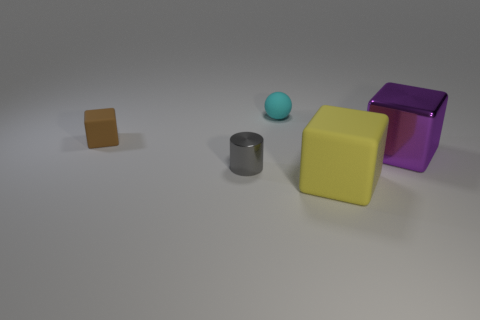There is a tiny cyan object that is made of the same material as the yellow object; what is its shape?
Your answer should be very brief. Sphere. Is there any other thing that has the same color as the tiny block?
Offer a terse response. No. What is the small object that is behind the matte cube on the left side of the small cyan sphere made of?
Offer a very short reply. Rubber. Are there any tiny cyan objects of the same shape as the big yellow matte thing?
Give a very brief answer. No. How many other things are the same shape as the yellow matte object?
Offer a terse response. 2. The object that is both behind the small gray object and in front of the brown rubber thing has what shape?
Keep it short and to the point. Cube. There is a shiny object in front of the large metallic object; how big is it?
Provide a short and direct response. Small. Do the gray metallic object and the brown cube have the same size?
Keep it short and to the point. Yes. Are there fewer small cyan things on the left side of the small gray object than cyan balls to the left of the large yellow rubber block?
Your answer should be compact. Yes. How big is the object that is both in front of the shiny block and left of the yellow rubber object?
Offer a terse response. Small. 